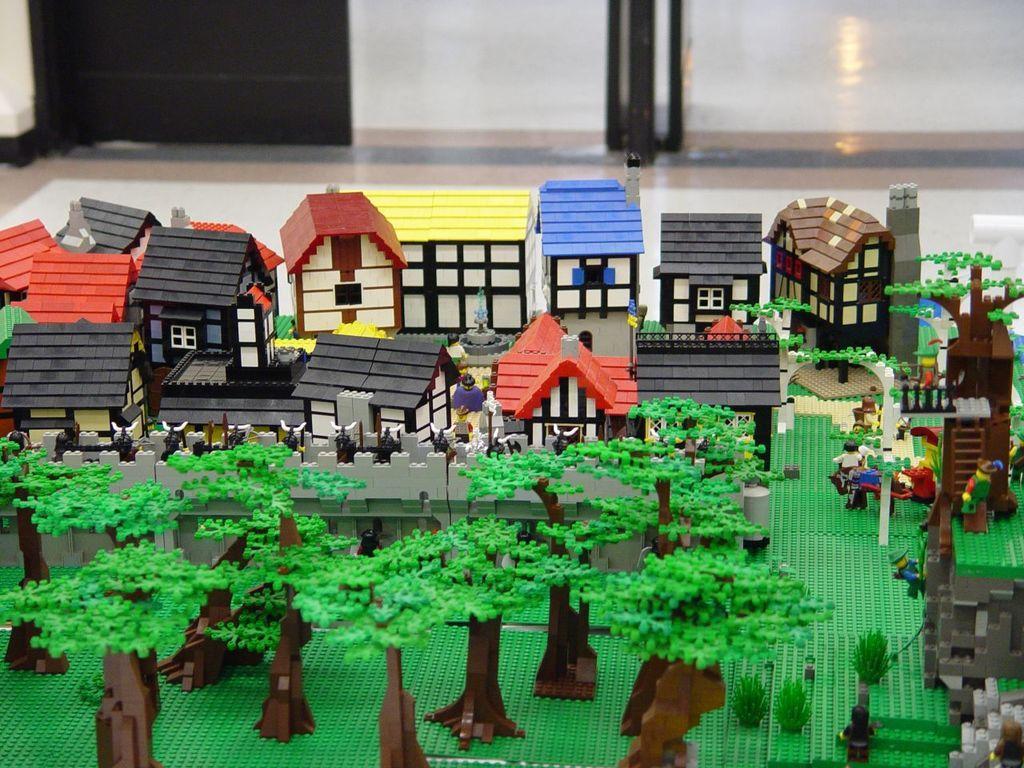In one or two sentences, can you explain what this image depicts? In this image, we can see some toys like houses, people and trees. We can also see the floor. 